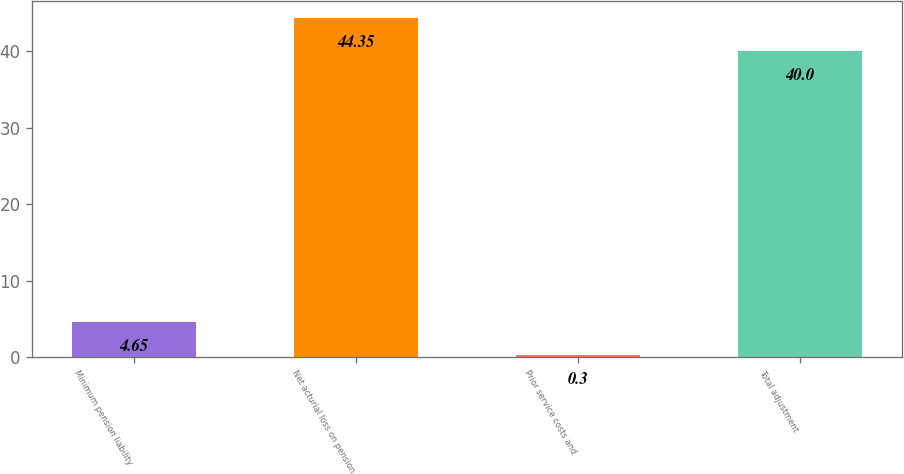<chart> <loc_0><loc_0><loc_500><loc_500><bar_chart><fcel>Minimum pension liability<fcel>Net acturial loss on pension<fcel>Prior service costs and<fcel>Total adjustment<nl><fcel>4.65<fcel>44.35<fcel>0.3<fcel>40<nl></chart> 